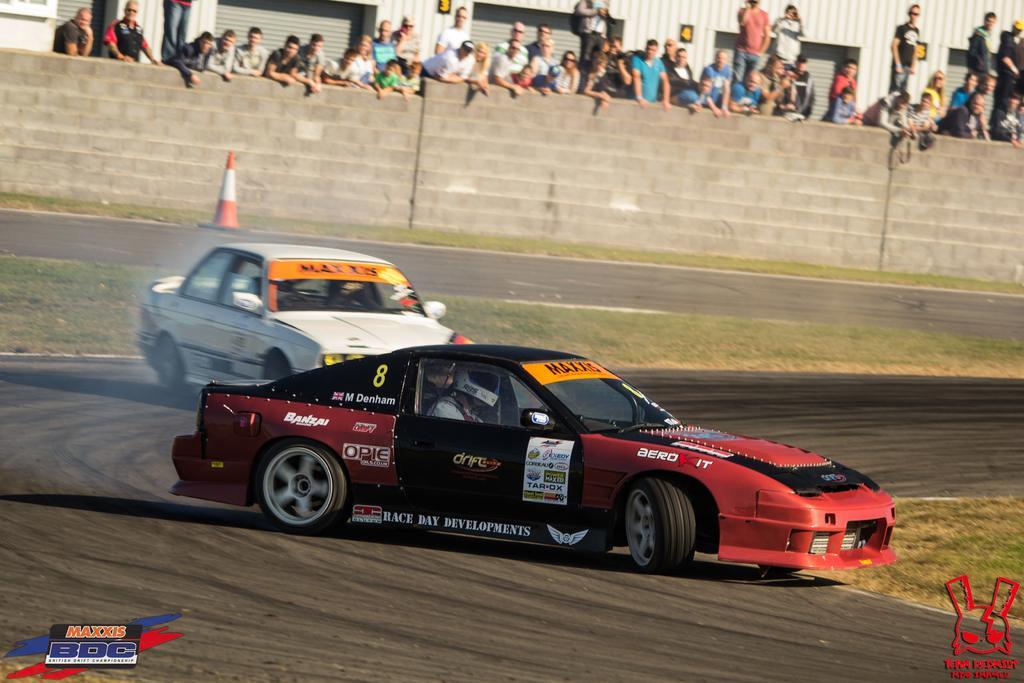Please provide a concise description of this image. In the center of the image there are two cars. In the background of the there are people standing. There is a wall. There is a safety cone. There is grass. 